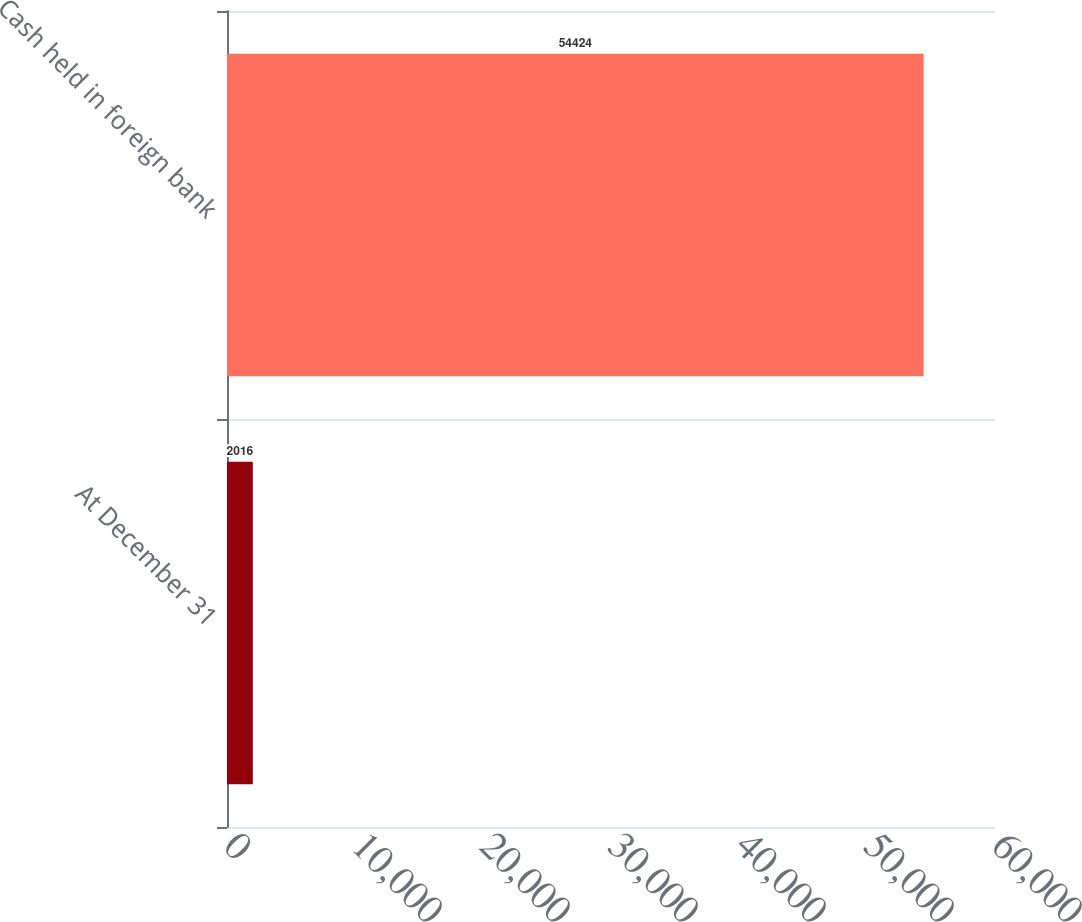Convert chart. <chart><loc_0><loc_0><loc_500><loc_500><bar_chart><fcel>At December 31<fcel>Cash held in foreign bank<nl><fcel>2016<fcel>54424<nl></chart> 